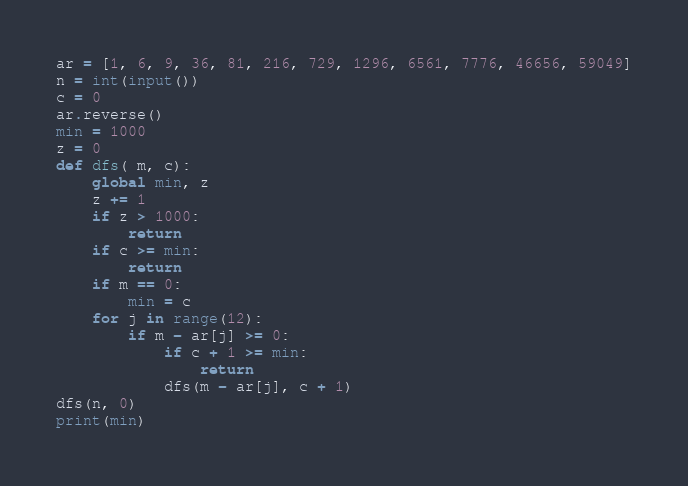<code> <loc_0><loc_0><loc_500><loc_500><_Python_>ar = [1, 6, 9, 36, 81, 216, 729, 1296, 6561, 7776, 46656, 59049]
n = int(input())
c = 0
ar.reverse()
min = 1000
z = 0
def dfs( m, c):
    global min, z
    z += 1
    if z > 1000:
        return
    if c >= min:
        return
    if m == 0:
        min = c
    for j in range(12):
        if m - ar[j] >= 0:
            if c + 1 >= min:
                return
            dfs(m - ar[j], c + 1)
dfs(n, 0)
print(min)</code> 